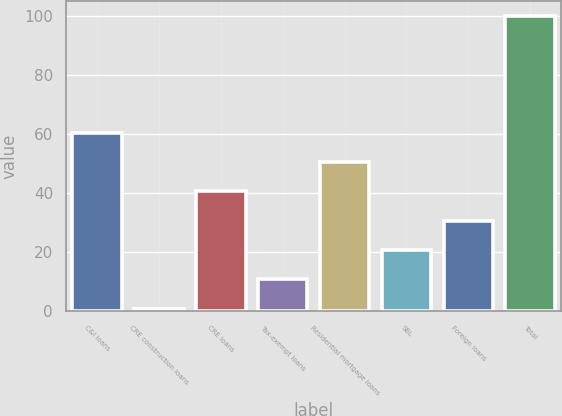Convert chart. <chart><loc_0><loc_0><loc_500><loc_500><bar_chart><fcel>C&I loans<fcel>CRE construction loans<fcel>CRE loans<fcel>Tax-exempt loans<fcel>Residential mortgage loans<fcel>SBL<fcel>Foreign loans<fcel>Total<nl><fcel>60.4<fcel>1<fcel>40.6<fcel>10.9<fcel>50.5<fcel>20.8<fcel>30.7<fcel>100<nl></chart> 